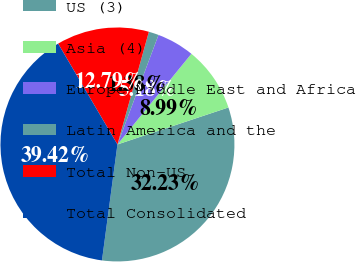<chart> <loc_0><loc_0><loc_500><loc_500><pie_chart><fcel>US (3)<fcel>Asia (4)<fcel>Europe Middle East and Africa<fcel>Latin America and the<fcel>Total Non-US<fcel>Total Consolidated<nl><fcel>32.23%<fcel>8.99%<fcel>5.18%<fcel>1.38%<fcel>12.79%<fcel>39.42%<nl></chart> 